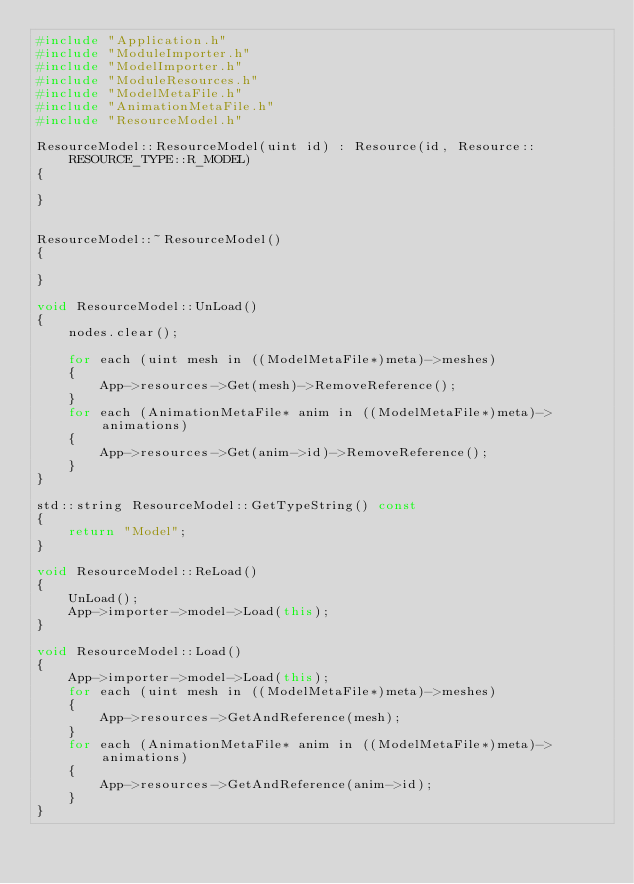<code> <loc_0><loc_0><loc_500><loc_500><_C++_>#include "Application.h"
#include "ModuleImporter.h"
#include "ModelImporter.h"
#include "ModuleResources.h"
#include "ModelMetaFile.h"
#include "AnimationMetaFile.h"
#include "ResourceModel.h"

ResourceModel::ResourceModel(uint id) : Resource(id, Resource::RESOURCE_TYPE::R_MODEL)
{

}


ResourceModel::~ResourceModel()
{

}

void ResourceModel::UnLoad()
{
	nodes.clear();

	for each (uint mesh in ((ModelMetaFile*)meta)->meshes)
	{
		App->resources->Get(mesh)->RemoveReference();
	}
	for each (AnimationMetaFile* anim in ((ModelMetaFile*)meta)->animations)
	{
		App->resources->Get(anim->id)->RemoveReference();
	}
}

std::string ResourceModel::GetTypeString() const
{
	return "Model";
}

void ResourceModel::ReLoad()
{
	UnLoad();
	App->importer->model->Load(this);
}

void ResourceModel::Load()
{
	App->importer->model->Load(this);
	for each (uint mesh in ((ModelMetaFile*)meta)->meshes)
	{
		App->resources->GetAndReference(mesh);
	}
	for each (AnimationMetaFile* anim in ((ModelMetaFile*)meta)->animations)
	{
		App->resources->GetAndReference(anim->id);
	}
}
</code> 